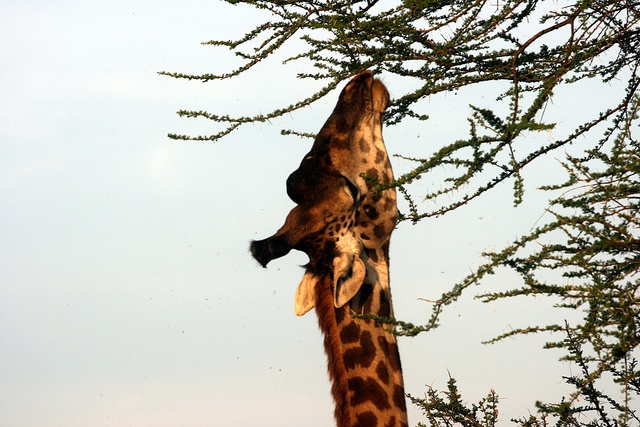Describe the objects in this image and their specific colors. I can see a giraffe in white, black, maroon, brown, and orange tones in this image. 